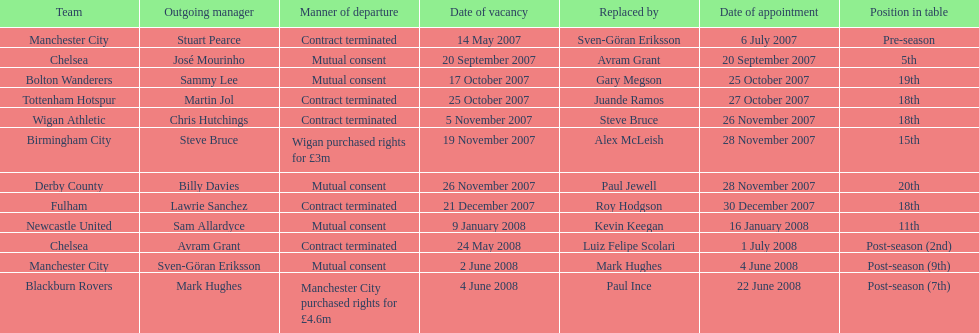In 2007, when stuart pearce left manchester city, who succeeded him as the team's manager? Sven-Göran Eriksson. 